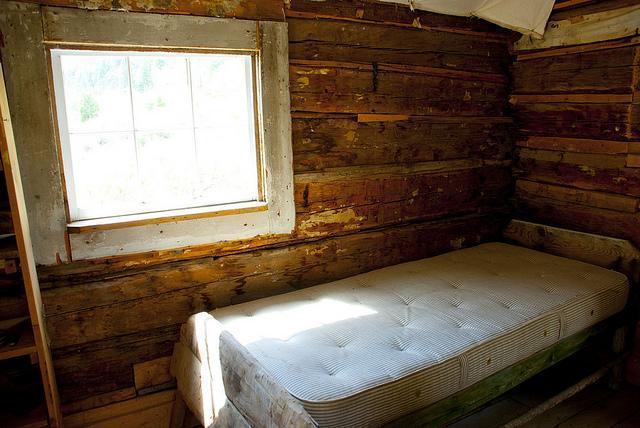How many people are on their phones listening to music?
Give a very brief answer. 0. 